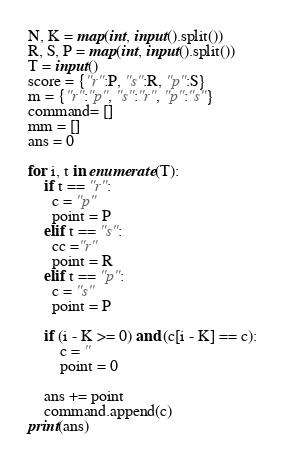Convert code to text. <code><loc_0><loc_0><loc_500><loc_500><_Python_>N, K = map(int, input().split())
R, S, P = map(int, input().split())
T = input()
score = {"r":P, "s":R, "p":S} 
m = {"r":"p", "s":"r", "p":"s"}
command= []
mm = []
ans = 0

for i, t in enumerate(T):
    if t == "r":
      c = "p"
      point = P
    elif t == "s":
      cc ="r" 
      point = R
    elif t == "p":
      c = "s"
      point = P
    
    if (i - K >= 0) and (c[i - K] == c):
        c = ''
        point = 0
    
    ans += point
    command.append(c)
print(ans)</code> 